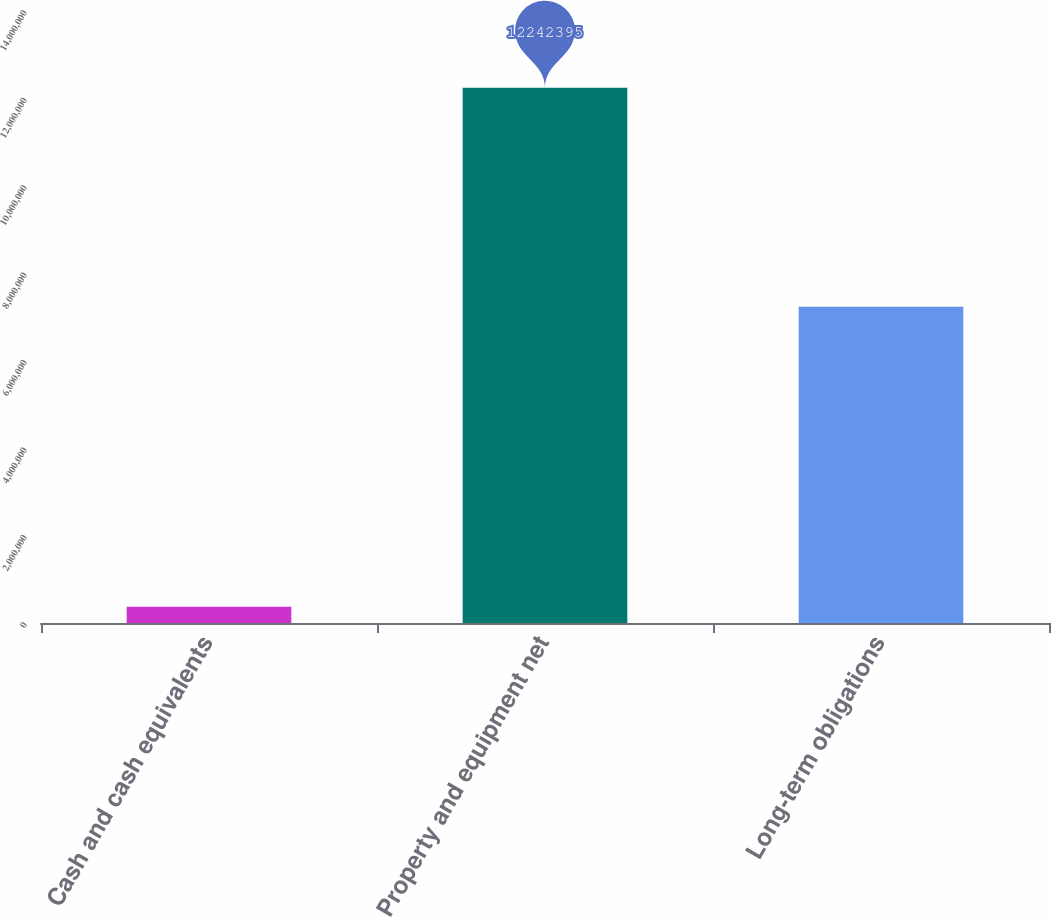Convert chart. <chart><loc_0><loc_0><loc_500><loc_500><bar_chart><fcel>Cash and cash equivalents<fcel>Property and equipment net<fcel>Long-term obligations<nl><fcel>372406<fcel>1.22424e+07<fcel>7.23631e+06<nl></chart> 